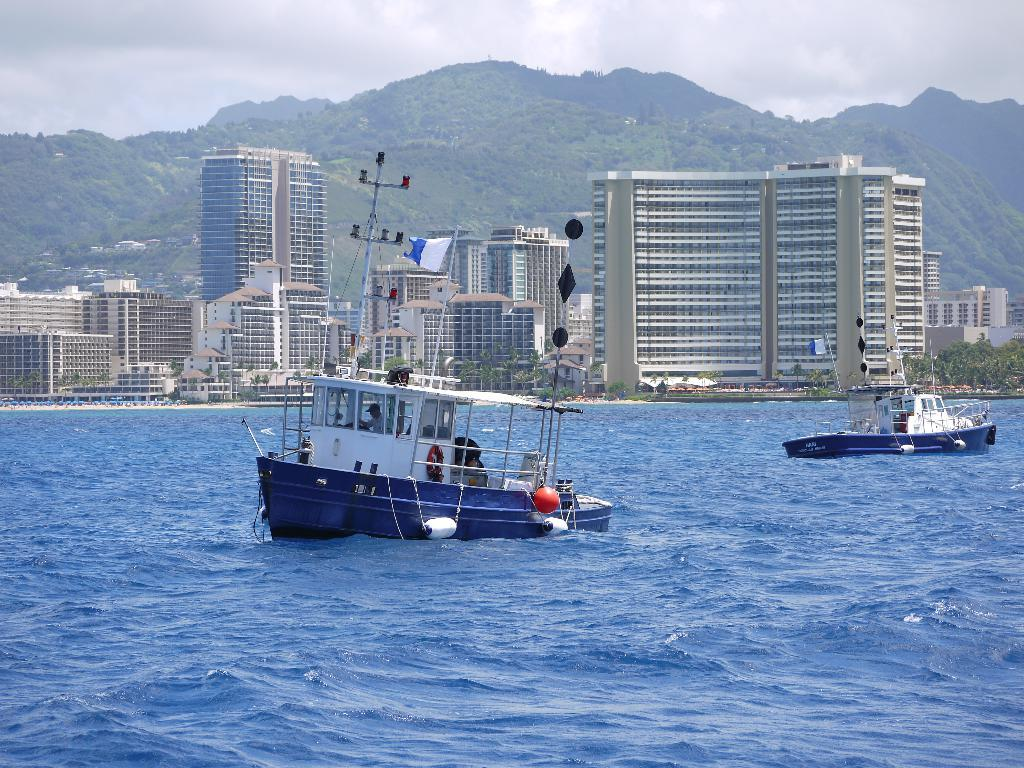How many boats are in the water in the image? There are two boats in the water in the image. What can be seen on the boats? The boats have flags and swim tubes. Is there anyone on the boats? Yes, there is a person on one of the boats. What can be seen in the background of the image? There are buildings, trees, mountains, and some unspecified objects in the background. What is visible in the sky in the image? The sky is visible in the background of the image. What type of quicksand can be seen in the image? There is no quicksand present in the image. What is the taste of the oil in the image? There is no oil present in the image, so it cannot be tasted. 